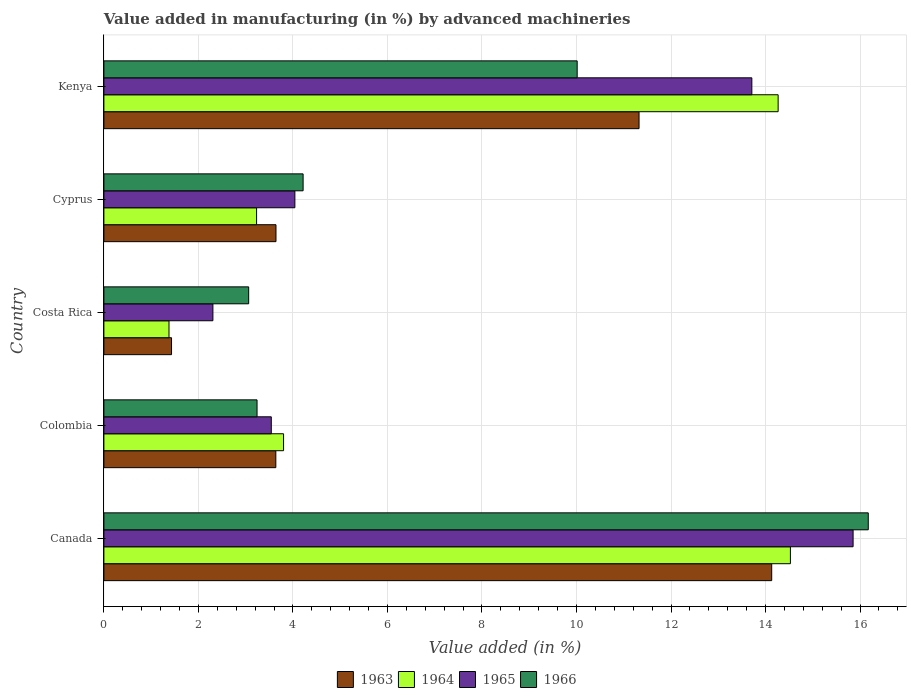How many groups of bars are there?
Provide a short and direct response. 5. Are the number of bars per tick equal to the number of legend labels?
Give a very brief answer. Yes. How many bars are there on the 5th tick from the top?
Keep it short and to the point. 4. How many bars are there on the 1st tick from the bottom?
Provide a short and direct response. 4. What is the label of the 5th group of bars from the top?
Keep it short and to the point. Canada. In how many cases, is the number of bars for a given country not equal to the number of legend labels?
Offer a very short reply. 0. What is the percentage of value added in manufacturing by advanced machineries in 1964 in Costa Rica?
Ensure brevity in your answer.  1.38. Across all countries, what is the maximum percentage of value added in manufacturing by advanced machineries in 1965?
Make the answer very short. 15.85. Across all countries, what is the minimum percentage of value added in manufacturing by advanced machineries in 1963?
Ensure brevity in your answer.  1.43. What is the total percentage of value added in manufacturing by advanced machineries in 1964 in the graph?
Make the answer very short. 37.2. What is the difference between the percentage of value added in manufacturing by advanced machineries in 1965 in Colombia and that in Kenya?
Your response must be concise. -10.17. What is the difference between the percentage of value added in manufacturing by advanced machineries in 1966 in Colombia and the percentage of value added in manufacturing by advanced machineries in 1964 in Kenya?
Your answer should be very brief. -11.03. What is the average percentage of value added in manufacturing by advanced machineries in 1964 per country?
Your answer should be very brief. 7.44. What is the difference between the percentage of value added in manufacturing by advanced machineries in 1963 and percentage of value added in manufacturing by advanced machineries in 1966 in Costa Rica?
Ensure brevity in your answer.  -1.63. What is the ratio of the percentage of value added in manufacturing by advanced machineries in 1966 in Canada to that in Kenya?
Your answer should be very brief. 1.62. Is the percentage of value added in manufacturing by advanced machineries in 1964 in Colombia less than that in Cyprus?
Provide a short and direct response. No. Is the difference between the percentage of value added in manufacturing by advanced machineries in 1963 in Canada and Kenya greater than the difference between the percentage of value added in manufacturing by advanced machineries in 1966 in Canada and Kenya?
Ensure brevity in your answer.  No. What is the difference between the highest and the second highest percentage of value added in manufacturing by advanced machineries in 1963?
Make the answer very short. 2.81. What is the difference between the highest and the lowest percentage of value added in manufacturing by advanced machineries in 1963?
Offer a very short reply. 12.7. Is the sum of the percentage of value added in manufacturing by advanced machineries in 1964 in Costa Rica and Cyprus greater than the maximum percentage of value added in manufacturing by advanced machineries in 1966 across all countries?
Ensure brevity in your answer.  No. What does the 4th bar from the top in Kenya represents?
Your response must be concise. 1963. What does the 2nd bar from the bottom in Canada represents?
Keep it short and to the point. 1964. How many bars are there?
Offer a terse response. 20. How many countries are there in the graph?
Make the answer very short. 5. What is the difference between two consecutive major ticks on the X-axis?
Ensure brevity in your answer.  2. Does the graph contain grids?
Provide a succinct answer. Yes. Where does the legend appear in the graph?
Your answer should be compact. Bottom center. How many legend labels are there?
Provide a succinct answer. 4. What is the title of the graph?
Your answer should be compact. Value added in manufacturing (in %) by advanced machineries. What is the label or title of the X-axis?
Give a very brief answer. Value added (in %). What is the Value added (in %) of 1963 in Canada?
Your answer should be compact. 14.13. What is the Value added (in %) in 1964 in Canada?
Offer a terse response. 14.53. What is the Value added (in %) of 1965 in Canada?
Offer a terse response. 15.85. What is the Value added (in %) in 1966 in Canada?
Your answer should be compact. 16.17. What is the Value added (in %) in 1963 in Colombia?
Keep it short and to the point. 3.64. What is the Value added (in %) in 1964 in Colombia?
Provide a succinct answer. 3.8. What is the Value added (in %) of 1965 in Colombia?
Provide a succinct answer. 3.54. What is the Value added (in %) of 1966 in Colombia?
Make the answer very short. 3.24. What is the Value added (in %) of 1963 in Costa Rica?
Give a very brief answer. 1.43. What is the Value added (in %) of 1964 in Costa Rica?
Your response must be concise. 1.38. What is the Value added (in %) of 1965 in Costa Rica?
Offer a terse response. 2.31. What is the Value added (in %) in 1966 in Costa Rica?
Ensure brevity in your answer.  3.06. What is the Value added (in %) of 1963 in Cyprus?
Your answer should be very brief. 3.64. What is the Value added (in %) of 1964 in Cyprus?
Your answer should be very brief. 3.23. What is the Value added (in %) of 1965 in Cyprus?
Offer a terse response. 4.04. What is the Value added (in %) of 1966 in Cyprus?
Offer a very short reply. 4.22. What is the Value added (in %) in 1963 in Kenya?
Offer a terse response. 11.32. What is the Value added (in %) in 1964 in Kenya?
Ensure brevity in your answer.  14.27. What is the Value added (in %) in 1965 in Kenya?
Offer a very short reply. 13.71. What is the Value added (in %) in 1966 in Kenya?
Keep it short and to the point. 10.01. Across all countries, what is the maximum Value added (in %) of 1963?
Offer a terse response. 14.13. Across all countries, what is the maximum Value added (in %) in 1964?
Your response must be concise. 14.53. Across all countries, what is the maximum Value added (in %) in 1965?
Your answer should be very brief. 15.85. Across all countries, what is the maximum Value added (in %) in 1966?
Offer a very short reply. 16.17. Across all countries, what is the minimum Value added (in %) in 1963?
Provide a succinct answer. 1.43. Across all countries, what is the minimum Value added (in %) in 1964?
Offer a terse response. 1.38. Across all countries, what is the minimum Value added (in %) in 1965?
Your response must be concise. 2.31. Across all countries, what is the minimum Value added (in %) of 1966?
Offer a terse response. 3.06. What is the total Value added (in %) in 1963 in the graph?
Provide a succinct answer. 34.16. What is the total Value added (in %) of 1964 in the graph?
Offer a terse response. 37.2. What is the total Value added (in %) of 1965 in the graph?
Provide a succinct answer. 39.45. What is the total Value added (in %) of 1966 in the graph?
Give a very brief answer. 36.71. What is the difference between the Value added (in %) in 1963 in Canada and that in Colombia?
Provide a succinct answer. 10.49. What is the difference between the Value added (in %) in 1964 in Canada and that in Colombia?
Your response must be concise. 10.72. What is the difference between the Value added (in %) in 1965 in Canada and that in Colombia?
Provide a short and direct response. 12.31. What is the difference between the Value added (in %) of 1966 in Canada and that in Colombia?
Ensure brevity in your answer.  12.93. What is the difference between the Value added (in %) in 1963 in Canada and that in Costa Rica?
Your answer should be very brief. 12.7. What is the difference between the Value added (in %) in 1964 in Canada and that in Costa Rica?
Your response must be concise. 13.15. What is the difference between the Value added (in %) in 1965 in Canada and that in Costa Rica?
Offer a terse response. 13.55. What is the difference between the Value added (in %) of 1966 in Canada and that in Costa Rica?
Ensure brevity in your answer.  13.11. What is the difference between the Value added (in %) in 1963 in Canada and that in Cyprus?
Offer a terse response. 10.49. What is the difference between the Value added (in %) in 1964 in Canada and that in Cyprus?
Offer a terse response. 11.3. What is the difference between the Value added (in %) of 1965 in Canada and that in Cyprus?
Provide a short and direct response. 11.81. What is the difference between the Value added (in %) of 1966 in Canada and that in Cyprus?
Your response must be concise. 11.96. What is the difference between the Value added (in %) of 1963 in Canada and that in Kenya?
Provide a succinct answer. 2.81. What is the difference between the Value added (in %) in 1964 in Canada and that in Kenya?
Give a very brief answer. 0.26. What is the difference between the Value added (in %) in 1965 in Canada and that in Kenya?
Your answer should be very brief. 2.14. What is the difference between the Value added (in %) of 1966 in Canada and that in Kenya?
Make the answer very short. 6.16. What is the difference between the Value added (in %) in 1963 in Colombia and that in Costa Rica?
Provide a succinct answer. 2.21. What is the difference between the Value added (in %) in 1964 in Colombia and that in Costa Rica?
Offer a very short reply. 2.42. What is the difference between the Value added (in %) in 1965 in Colombia and that in Costa Rica?
Offer a very short reply. 1.24. What is the difference between the Value added (in %) of 1966 in Colombia and that in Costa Rica?
Give a very brief answer. 0.18. What is the difference between the Value added (in %) in 1963 in Colombia and that in Cyprus?
Give a very brief answer. -0. What is the difference between the Value added (in %) in 1964 in Colombia and that in Cyprus?
Give a very brief answer. 0.57. What is the difference between the Value added (in %) in 1965 in Colombia and that in Cyprus?
Provide a succinct answer. -0.5. What is the difference between the Value added (in %) in 1966 in Colombia and that in Cyprus?
Ensure brevity in your answer.  -0.97. What is the difference between the Value added (in %) of 1963 in Colombia and that in Kenya?
Provide a short and direct response. -7.69. What is the difference between the Value added (in %) of 1964 in Colombia and that in Kenya?
Make the answer very short. -10.47. What is the difference between the Value added (in %) of 1965 in Colombia and that in Kenya?
Keep it short and to the point. -10.17. What is the difference between the Value added (in %) in 1966 in Colombia and that in Kenya?
Your answer should be very brief. -6.77. What is the difference between the Value added (in %) in 1963 in Costa Rica and that in Cyprus?
Your answer should be very brief. -2.21. What is the difference between the Value added (in %) of 1964 in Costa Rica and that in Cyprus?
Make the answer very short. -1.85. What is the difference between the Value added (in %) of 1965 in Costa Rica and that in Cyprus?
Offer a terse response. -1.73. What is the difference between the Value added (in %) of 1966 in Costa Rica and that in Cyprus?
Your response must be concise. -1.15. What is the difference between the Value added (in %) in 1963 in Costa Rica and that in Kenya?
Make the answer very short. -9.89. What is the difference between the Value added (in %) of 1964 in Costa Rica and that in Kenya?
Your response must be concise. -12.89. What is the difference between the Value added (in %) of 1965 in Costa Rica and that in Kenya?
Make the answer very short. -11.4. What is the difference between the Value added (in %) of 1966 in Costa Rica and that in Kenya?
Offer a very short reply. -6.95. What is the difference between the Value added (in %) in 1963 in Cyprus and that in Kenya?
Provide a succinct answer. -7.68. What is the difference between the Value added (in %) in 1964 in Cyprus and that in Kenya?
Your response must be concise. -11.04. What is the difference between the Value added (in %) in 1965 in Cyprus and that in Kenya?
Offer a terse response. -9.67. What is the difference between the Value added (in %) in 1966 in Cyprus and that in Kenya?
Offer a very short reply. -5.8. What is the difference between the Value added (in %) in 1963 in Canada and the Value added (in %) in 1964 in Colombia?
Keep it short and to the point. 10.33. What is the difference between the Value added (in %) of 1963 in Canada and the Value added (in %) of 1965 in Colombia?
Ensure brevity in your answer.  10.59. What is the difference between the Value added (in %) in 1963 in Canada and the Value added (in %) in 1966 in Colombia?
Give a very brief answer. 10.89. What is the difference between the Value added (in %) in 1964 in Canada and the Value added (in %) in 1965 in Colombia?
Give a very brief answer. 10.98. What is the difference between the Value added (in %) of 1964 in Canada and the Value added (in %) of 1966 in Colombia?
Give a very brief answer. 11.29. What is the difference between the Value added (in %) in 1965 in Canada and the Value added (in %) in 1966 in Colombia?
Give a very brief answer. 12.61. What is the difference between the Value added (in %) in 1963 in Canada and the Value added (in %) in 1964 in Costa Rica?
Offer a very short reply. 12.75. What is the difference between the Value added (in %) of 1963 in Canada and the Value added (in %) of 1965 in Costa Rica?
Your answer should be very brief. 11.82. What is the difference between the Value added (in %) of 1963 in Canada and the Value added (in %) of 1966 in Costa Rica?
Your answer should be compact. 11.07. What is the difference between the Value added (in %) in 1964 in Canada and the Value added (in %) in 1965 in Costa Rica?
Provide a succinct answer. 12.22. What is the difference between the Value added (in %) of 1964 in Canada and the Value added (in %) of 1966 in Costa Rica?
Your answer should be very brief. 11.46. What is the difference between the Value added (in %) in 1965 in Canada and the Value added (in %) in 1966 in Costa Rica?
Your response must be concise. 12.79. What is the difference between the Value added (in %) of 1963 in Canada and the Value added (in %) of 1964 in Cyprus?
Keep it short and to the point. 10.9. What is the difference between the Value added (in %) in 1963 in Canada and the Value added (in %) in 1965 in Cyprus?
Offer a terse response. 10.09. What is the difference between the Value added (in %) of 1963 in Canada and the Value added (in %) of 1966 in Cyprus?
Keep it short and to the point. 9.92. What is the difference between the Value added (in %) in 1964 in Canada and the Value added (in %) in 1965 in Cyprus?
Give a very brief answer. 10.49. What is the difference between the Value added (in %) in 1964 in Canada and the Value added (in %) in 1966 in Cyprus?
Offer a very short reply. 10.31. What is the difference between the Value added (in %) in 1965 in Canada and the Value added (in %) in 1966 in Cyprus?
Ensure brevity in your answer.  11.64. What is the difference between the Value added (in %) in 1963 in Canada and the Value added (in %) in 1964 in Kenya?
Give a very brief answer. -0.14. What is the difference between the Value added (in %) in 1963 in Canada and the Value added (in %) in 1965 in Kenya?
Offer a terse response. 0.42. What is the difference between the Value added (in %) of 1963 in Canada and the Value added (in %) of 1966 in Kenya?
Offer a very short reply. 4.12. What is the difference between the Value added (in %) in 1964 in Canada and the Value added (in %) in 1965 in Kenya?
Give a very brief answer. 0.82. What is the difference between the Value added (in %) in 1964 in Canada and the Value added (in %) in 1966 in Kenya?
Provide a short and direct response. 4.51. What is the difference between the Value added (in %) of 1965 in Canada and the Value added (in %) of 1966 in Kenya?
Your answer should be compact. 5.84. What is the difference between the Value added (in %) of 1963 in Colombia and the Value added (in %) of 1964 in Costa Rica?
Provide a short and direct response. 2.26. What is the difference between the Value added (in %) in 1963 in Colombia and the Value added (in %) in 1965 in Costa Rica?
Give a very brief answer. 1.33. What is the difference between the Value added (in %) of 1963 in Colombia and the Value added (in %) of 1966 in Costa Rica?
Offer a terse response. 0.57. What is the difference between the Value added (in %) in 1964 in Colombia and the Value added (in %) in 1965 in Costa Rica?
Ensure brevity in your answer.  1.49. What is the difference between the Value added (in %) in 1964 in Colombia and the Value added (in %) in 1966 in Costa Rica?
Your response must be concise. 0.74. What is the difference between the Value added (in %) of 1965 in Colombia and the Value added (in %) of 1966 in Costa Rica?
Provide a short and direct response. 0.48. What is the difference between the Value added (in %) of 1963 in Colombia and the Value added (in %) of 1964 in Cyprus?
Make the answer very short. 0.41. What is the difference between the Value added (in %) in 1963 in Colombia and the Value added (in %) in 1965 in Cyprus?
Your answer should be compact. -0.4. What is the difference between the Value added (in %) of 1963 in Colombia and the Value added (in %) of 1966 in Cyprus?
Offer a terse response. -0.58. What is the difference between the Value added (in %) in 1964 in Colombia and the Value added (in %) in 1965 in Cyprus?
Give a very brief answer. -0.24. What is the difference between the Value added (in %) of 1964 in Colombia and the Value added (in %) of 1966 in Cyprus?
Keep it short and to the point. -0.41. What is the difference between the Value added (in %) in 1965 in Colombia and the Value added (in %) in 1966 in Cyprus?
Offer a terse response. -0.67. What is the difference between the Value added (in %) of 1963 in Colombia and the Value added (in %) of 1964 in Kenya?
Your answer should be very brief. -10.63. What is the difference between the Value added (in %) of 1963 in Colombia and the Value added (in %) of 1965 in Kenya?
Offer a terse response. -10.07. What is the difference between the Value added (in %) of 1963 in Colombia and the Value added (in %) of 1966 in Kenya?
Your answer should be compact. -6.38. What is the difference between the Value added (in %) in 1964 in Colombia and the Value added (in %) in 1965 in Kenya?
Ensure brevity in your answer.  -9.91. What is the difference between the Value added (in %) of 1964 in Colombia and the Value added (in %) of 1966 in Kenya?
Your answer should be compact. -6.21. What is the difference between the Value added (in %) in 1965 in Colombia and the Value added (in %) in 1966 in Kenya?
Ensure brevity in your answer.  -6.47. What is the difference between the Value added (in %) in 1963 in Costa Rica and the Value added (in %) in 1964 in Cyprus?
Give a very brief answer. -1.8. What is the difference between the Value added (in %) of 1963 in Costa Rica and the Value added (in %) of 1965 in Cyprus?
Offer a very short reply. -2.61. What is the difference between the Value added (in %) in 1963 in Costa Rica and the Value added (in %) in 1966 in Cyprus?
Your answer should be compact. -2.78. What is the difference between the Value added (in %) in 1964 in Costa Rica and the Value added (in %) in 1965 in Cyprus?
Offer a terse response. -2.66. What is the difference between the Value added (in %) in 1964 in Costa Rica and the Value added (in %) in 1966 in Cyprus?
Your response must be concise. -2.84. What is the difference between the Value added (in %) of 1965 in Costa Rica and the Value added (in %) of 1966 in Cyprus?
Offer a very short reply. -1.91. What is the difference between the Value added (in %) of 1963 in Costa Rica and the Value added (in %) of 1964 in Kenya?
Your answer should be very brief. -12.84. What is the difference between the Value added (in %) of 1963 in Costa Rica and the Value added (in %) of 1965 in Kenya?
Give a very brief answer. -12.28. What is the difference between the Value added (in %) in 1963 in Costa Rica and the Value added (in %) in 1966 in Kenya?
Offer a very short reply. -8.58. What is the difference between the Value added (in %) in 1964 in Costa Rica and the Value added (in %) in 1965 in Kenya?
Offer a very short reply. -12.33. What is the difference between the Value added (in %) in 1964 in Costa Rica and the Value added (in %) in 1966 in Kenya?
Your response must be concise. -8.64. What is the difference between the Value added (in %) of 1965 in Costa Rica and the Value added (in %) of 1966 in Kenya?
Your response must be concise. -7.71. What is the difference between the Value added (in %) of 1963 in Cyprus and the Value added (in %) of 1964 in Kenya?
Offer a very short reply. -10.63. What is the difference between the Value added (in %) of 1963 in Cyprus and the Value added (in %) of 1965 in Kenya?
Offer a very short reply. -10.07. What is the difference between the Value added (in %) in 1963 in Cyprus and the Value added (in %) in 1966 in Kenya?
Ensure brevity in your answer.  -6.37. What is the difference between the Value added (in %) of 1964 in Cyprus and the Value added (in %) of 1965 in Kenya?
Provide a succinct answer. -10.48. What is the difference between the Value added (in %) of 1964 in Cyprus and the Value added (in %) of 1966 in Kenya?
Provide a short and direct response. -6.78. What is the difference between the Value added (in %) of 1965 in Cyprus and the Value added (in %) of 1966 in Kenya?
Make the answer very short. -5.97. What is the average Value added (in %) in 1963 per country?
Offer a terse response. 6.83. What is the average Value added (in %) in 1964 per country?
Provide a short and direct response. 7.44. What is the average Value added (in %) in 1965 per country?
Provide a short and direct response. 7.89. What is the average Value added (in %) of 1966 per country?
Keep it short and to the point. 7.34. What is the difference between the Value added (in %) in 1963 and Value added (in %) in 1964 in Canada?
Provide a short and direct response. -0.4. What is the difference between the Value added (in %) in 1963 and Value added (in %) in 1965 in Canada?
Your answer should be very brief. -1.72. What is the difference between the Value added (in %) in 1963 and Value added (in %) in 1966 in Canada?
Ensure brevity in your answer.  -2.04. What is the difference between the Value added (in %) of 1964 and Value added (in %) of 1965 in Canada?
Your answer should be very brief. -1.33. What is the difference between the Value added (in %) of 1964 and Value added (in %) of 1966 in Canada?
Offer a very short reply. -1.65. What is the difference between the Value added (in %) in 1965 and Value added (in %) in 1966 in Canada?
Your response must be concise. -0.32. What is the difference between the Value added (in %) in 1963 and Value added (in %) in 1964 in Colombia?
Your response must be concise. -0.16. What is the difference between the Value added (in %) in 1963 and Value added (in %) in 1965 in Colombia?
Provide a short and direct response. 0.1. What is the difference between the Value added (in %) of 1963 and Value added (in %) of 1966 in Colombia?
Keep it short and to the point. 0.4. What is the difference between the Value added (in %) of 1964 and Value added (in %) of 1965 in Colombia?
Offer a very short reply. 0.26. What is the difference between the Value added (in %) of 1964 and Value added (in %) of 1966 in Colombia?
Give a very brief answer. 0.56. What is the difference between the Value added (in %) of 1965 and Value added (in %) of 1966 in Colombia?
Your response must be concise. 0.3. What is the difference between the Value added (in %) in 1963 and Value added (in %) in 1964 in Costa Rica?
Give a very brief answer. 0.05. What is the difference between the Value added (in %) of 1963 and Value added (in %) of 1965 in Costa Rica?
Ensure brevity in your answer.  -0.88. What is the difference between the Value added (in %) in 1963 and Value added (in %) in 1966 in Costa Rica?
Your answer should be compact. -1.63. What is the difference between the Value added (in %) in 1964 and Value added (in %) in 1965 in Costa Rica?
Provide a short and direct response. -0.93. What is the difference between the Value added (in %) in 1964 and Value added (in %) in 1966 in Costa Rica?
Give a very brief answer. -1.69. What is the difference between the Value added (in %) of 1965 and Value added (in %) of 1966 in Costa Rica?
Provide a short and direct response. -0.76. What is the difference between the Value added (in %) in 1963 and Value added (in %) in 1964 in Cyprus?
Provide a succinct answer. 0.41. What is the difference between the Value added (in %) in 1963 and Value added (in %) in 1965 in Cyprus?
Keep it short and to the point. -0.4. What is the difference between the Value added (in %) in 1963 and Value added (in %) in 1966 in Cyprus?
Provide a succinct answer. -0.57. What is the difference between the Value added (in %) in 1964 and Value added (in %) in 1965 in Cyprus?
Provide a succinct answer. -0.81. What is the difference between the Value added (in %) in 1964 and Value added (in %) in 1966 in Cyprus?
Offer a very short reply. -0.98. What is the difference between the Value added (in %) of 1965 and Value added (in %) of 1966 in Cyprus?
Provide a short and direct response. -0.17. What is the difference between the Value added (in %) of 1963 and Value added (in %) of 1964 in Kenya?
Provide a succinct answer. -2.94. What is the difference between the Value added (in %) in 1963 and Value added (in %) in 1965 in Kenya?
Provide a short and direct response. -2.39. What is the difference between the Value added (in %) in 1963 and Value added (in %) in 1966 in Kenya?
Give a very brief answer. 1.31. What is the difference between the Value added (in %) of 1964 and Value added (in %) of 1965 in Kenya?
Provide a short and direct response. 0.56. What is the difference between the Value added (in %) in 1964 and Value added (in %) in 1966 in Kenya?
Provide a short and direct response. 4.25. What is the difference between the Value added (in %) of 1965 and Value added (in %) of 1966 in Kenya?
Your response must be concise. 3.7. What is the ratio of the Value added (in %) of 1963 in Canada to that in Colombia?
Your response must be concise. 3.88. What is the ratio of the Value added (in %) of 1964 in Canada to that in Colombia?
Provide a succinct answer. 3.82. What is the ratio of the Value added (in %) of 1965 in Canada to that in Colombia?
Keep it short and to the point. 4.48. What is the ratio of the Value added (in %) in 1966 in Canada to that in Colombia?
Make the answer very short. 4.99. What is the ratio of the Value added (in %) of 1963 in Canada to that in Costa Rica?
Make the answer very short. 9.87. What is the ratio of the Value added (in %) of 1964 in Canada to that in Costa Rica?
Provide a short and direct response. 10.54. What is the ratio of the Value added (in %) of 1965 in Canada to that in Costa Rica?
Offer a very short reply. 6.87. What is the ratio of the Value added (in %) of 1966 in Canada to that in Costa Rica?
Your answer should be compact. 5.28. What is the ratio of the Value added (in %) of 1963 in Canada to that in Cyprus?
Offer a terse response. 3.88. What is the ratio of the Value added (in %) in 1964 in Canada to that in Cyprus?
Your answer should be compact. 4.5. What is the ratio of the Value added (in %) in 1965 in Canada to that in Cyprus?
Give a very brief answer. 3.92. What is the ratio of the Value added (in %) of 1966 in Canada to that in Cyprus?
Your answer should be very brief. 3.84. What is the ratio of the Value added (in %) in 1963 in Canada to that in Kenya?
Your response must be concise. 1.25. What is the ratio of the Value added (in %) in 1964 in Canada to that in Kenya?
Your answer should be very brief. 1.02. What is the ratio of the Value added (in %) in 1965 in Canada to that in Kenya?
Keep it short and to the point. 1.16. What is the ratio of the Value added (in %) of 1966 in Canada to that in Kenya?
Your response must be concise. 1.62. What is the ratio of the Value added (in %) of 1963 in Colombia to that in Costa Rica?
Give a very brief answer. 2.54. What is the ratio of the Value added (in %) of 1964 in Colombia to that in Costa Rica?
Offer a terse response. 2.76. What is the ratio of the Value added (in %) in 1965 in Colombia to that in Costa Rica?
Your answer should be compact. 1.54. What is the ratio of the Value added (in %) of 1966 in Colombia to that in Costa Rica?
Make the answer very short. 1.06. What is the ratio of the Value added (in %) of 1963 in Colombia to that in Cyprus?
Provide a short and direct response. 1. What is the ratio of the Value added (in %) of 1964 in Colombia to that in Cyprus?
Ensure brevity in your answer.  1.18. What is the ratio of the Value added (in %) of 1965 in Colombia to that in Cyprus?
Give a very brief answer. 0.88. What is the ratio of the Value added (in %) of 1966 in Colombia to that in Cyprus?
Your answer should be compact. 0.77. What is the ratio of the Value added (in %) in 1963 in Colombia to that in Kenya?
Offer a terse response. 0.32. What is the ratio of the Value added (in %) in 1964 in Colombia to that in Kenya?
Give a very brief answer. 0.27. What is the ratio of the Value added (in %) in 1965 in Colombia to that in Kenya?
Offer a terse response. 0.26. What is the ratio of the Value added (in %) in 1966 in Colombia to that in Kenya?
Your answer should be very brief. 0.32. What is the ratio of the Value added (in %) of 1963 in Costa Rica to that in Cyprus?
Provide a short and direct response. 0.39. What is the ratio of the Value added (in %) of 1964 in Costa Rica to that in Cyprus?
Your answer should be compact. 0.43. What is the ratio of the Value added (in %) in 1965 in Costa Rica to that in Cyprus?
Make the answer very short. 0.57. What is the ratio of the Value added (in %) in 1966 in Costa Rica to that in Cyprus?
Your answer should be compact. 0.73. What is the ratio of the Value added (in %) in 1963 in Costa Rica to that in Kenya?
Ensure brevity in your answer.  0.13. What is the ratio of the Value added (in %) of 1964 in Costa Rica to that in Kenya?
Make the answer very short. 0.1. What is the ratio of the Value added (in %) of 1965 in Costa Rica to that in Kenya?
Keep it short and to the point. 0.17. What is the ratio of the Value added (in %) in 1966 in Costa Rica to that in Kenya?
Your answer should be very brief. 0.31. What is the ratio of the Value added (in %) in 1963 in Cyprus to that in Kenya?
Offer a very short reply. 0.32. What is the ratio of the Value added (in %) of 1964 in Cyprus to that in Kenya?
Make the answer very short. 0.23. What is the ratio of the Value added (in %) of 1965 in Cyprus to that in Kenya?
Provide a succinct answer. 0.29. What is the ratio of the Value added (in %) in 1966 in Cyprus to that in Kenya?
Offer a terse response. 0.42. What is the difference between the highest and the second highest Value added (in %) of 1963?
Provide a succinct answer. 2.81. What is the difference between the highest and the second highest Value added (in %) in 1964?
Your answer should be very brief. 0.26. What is the difference between the highest and the second highest Value added (in %) of 1965?
Your answer should be compact. 2.14. What is the difference between the highest and the second highest Value added (in %) in 1966?
Ensure brevity in your answer.  6.16. What is the difference between the highest and the lowest Value added (in %) of 1963?
Your answer should be very brief. 12.7. What is the difference between the highest and the lowest Value added (in %) in 1964?
Provide a short and direct response. 13.15. What is the difference between the highest and the lowest Value added (in %) of 1965?
Ensure brevity in your answer.  13.55. What is the difference between the highest and the lowest Value added (in %) in 1966?
Your answer should be very brief. 13.11. 